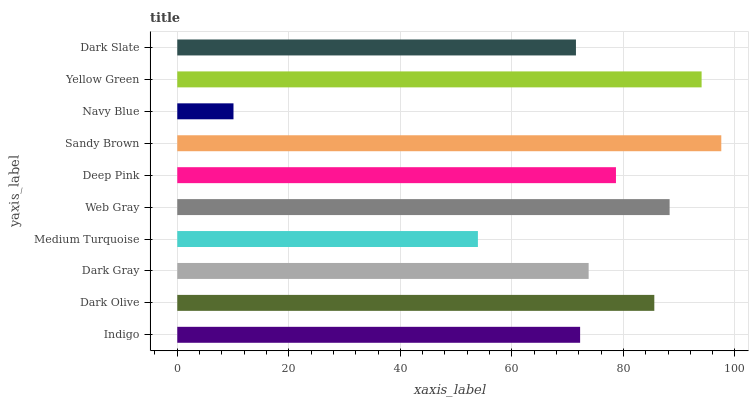Is Navy Blue the minimum?
Answer yes or no. Yes. Is Sandy Brown the maximum?
Answer yes or no. Yes. Is Dark Olive the minimum?
Answer yes or no. No. Is Dark Olive the maximum?
Answer yes or no. No. Is Dark Olive greater than Indigo?
Answer yes or no. Yes. Is Indigo less than Dark Olive?
Answer yes or no. Yes. Is Indigo greater than Dark Olive?
Answer yes or no. No. Is Dark Olive less than Indigo?
Answer yes or no. No. Is Deep Pink the high median?
Answer yes or no. Yes. Is Dark Gray the low median?
Answer yes or no. Yes. Is Dark Gray the high median?
Answer yes or no. No. Is Deep Pink the low median?
Answer yes or no. No. 